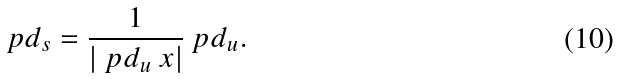Convert formula to latex. <formula><loc_0><loc_0><loc_500><loc_500>\ p d _ { s } = \frac { 1 } { \left | \ p d _ { u } \ x \right | } \ p d _ { u } .</formula> 